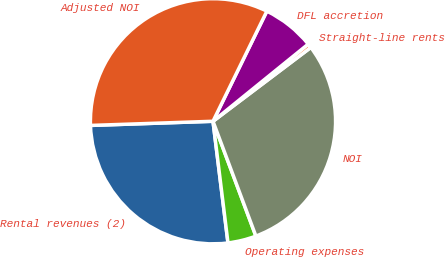<chart> <loc_0><loc_0><loc_500><loc_500><pie_chart><fcel>Rental revenues (2)<fcel>Operating expenses<fcel>NOI<fcel>Straight-line rents<fcel>DFL accretion<fcel>Adjusted NOI<nl><fcel>26.41%<fcel>3.74%<fcel>29.6%<fcel>0.55%<fcel>6.92%<fcel>32.78%<nl></chart> 